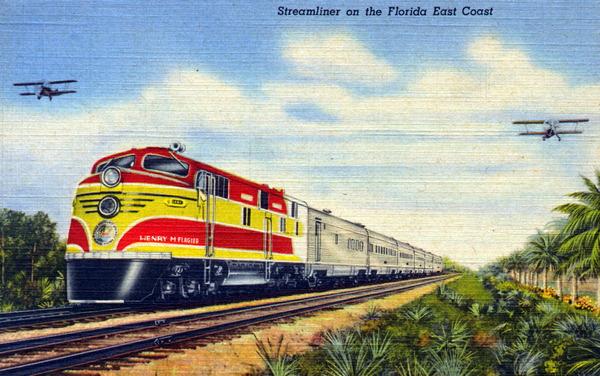Is this train in the middle of a city?
Give a very brief answer. No. What is the speed of this train?
Give a very brief answer. Fast. Are there planes in the sky?
Short answer required. Yes. 